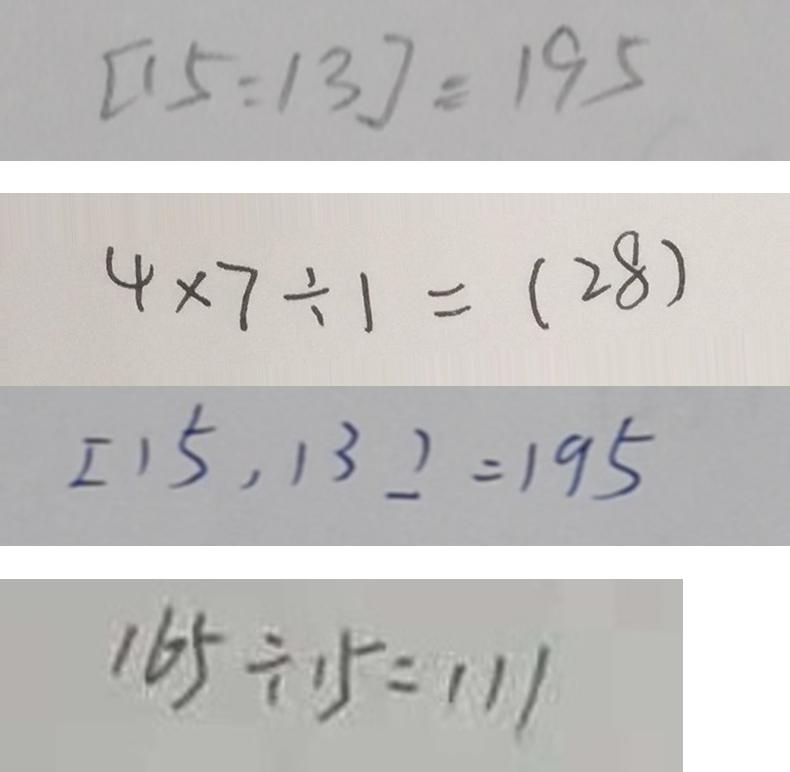Convert formula to latex. <formula><loc_0><loc_0><loc_500><loc_500>[ 1 5 : 1 3 ] = 1 9 5 
 4 \times 7 \div 1 = ( 2 8 ) 
 [ 1 5 , 1 3 ] = 1 9 5 
 1 6 5 \div 1 5 = 1 1 1</formula> 